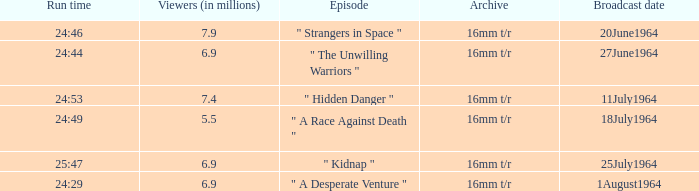How many viewers were there on 1august1964? 6.9. 